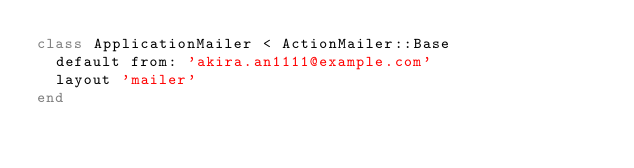Convert code to text. <code><loc_0><loc_0><loc_500><loc_500><_Ruby_>class ApplicationMailer < ActionMailer::Base
  default from: 'akira.an1111@example.com'
  layout 'mailer'
end
</code> 